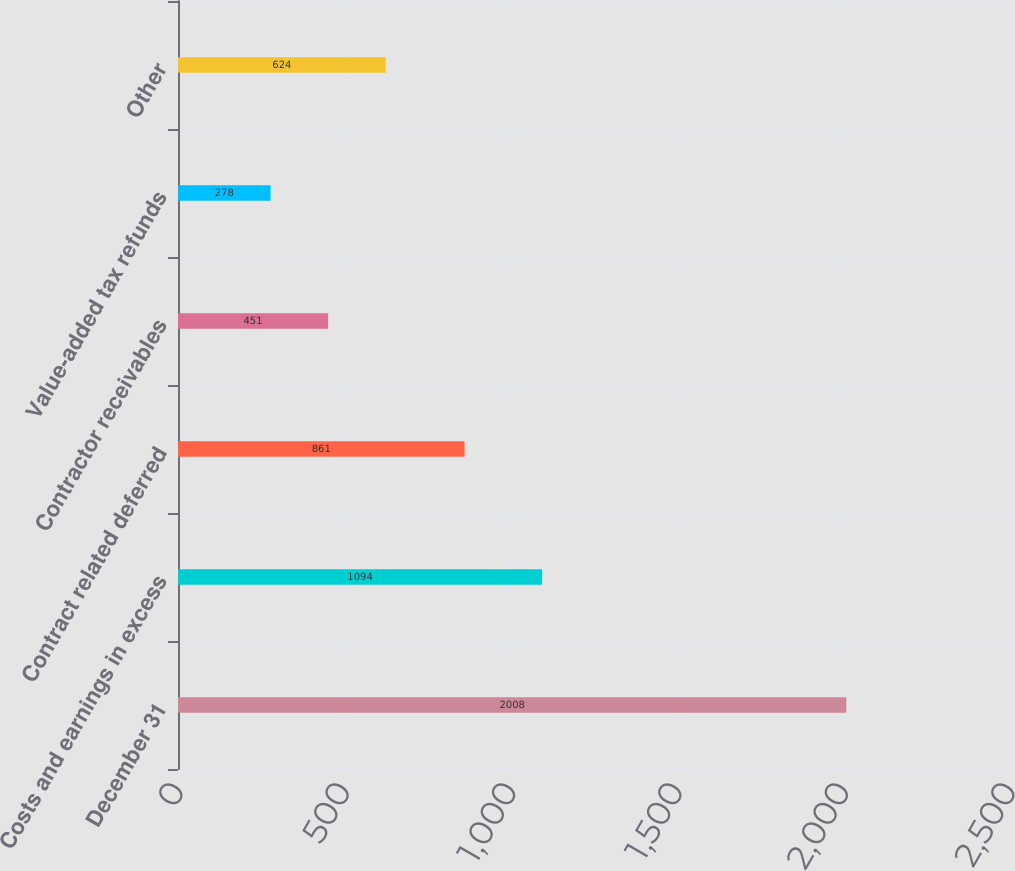<chart> <loc_0><loc_0><loc_500><loc_500><bar_chart><fcel>December 31<fcel>Costs and earnings in excess<fcel>Contract related deferred<fcel>Contractor receivables<fcel>Value-added tax refunds<fcel>Other<nl><fcel>2008<fcel>1094<fcel>861<fcel>451<fcel>278<fcel>624<nl></chart> 